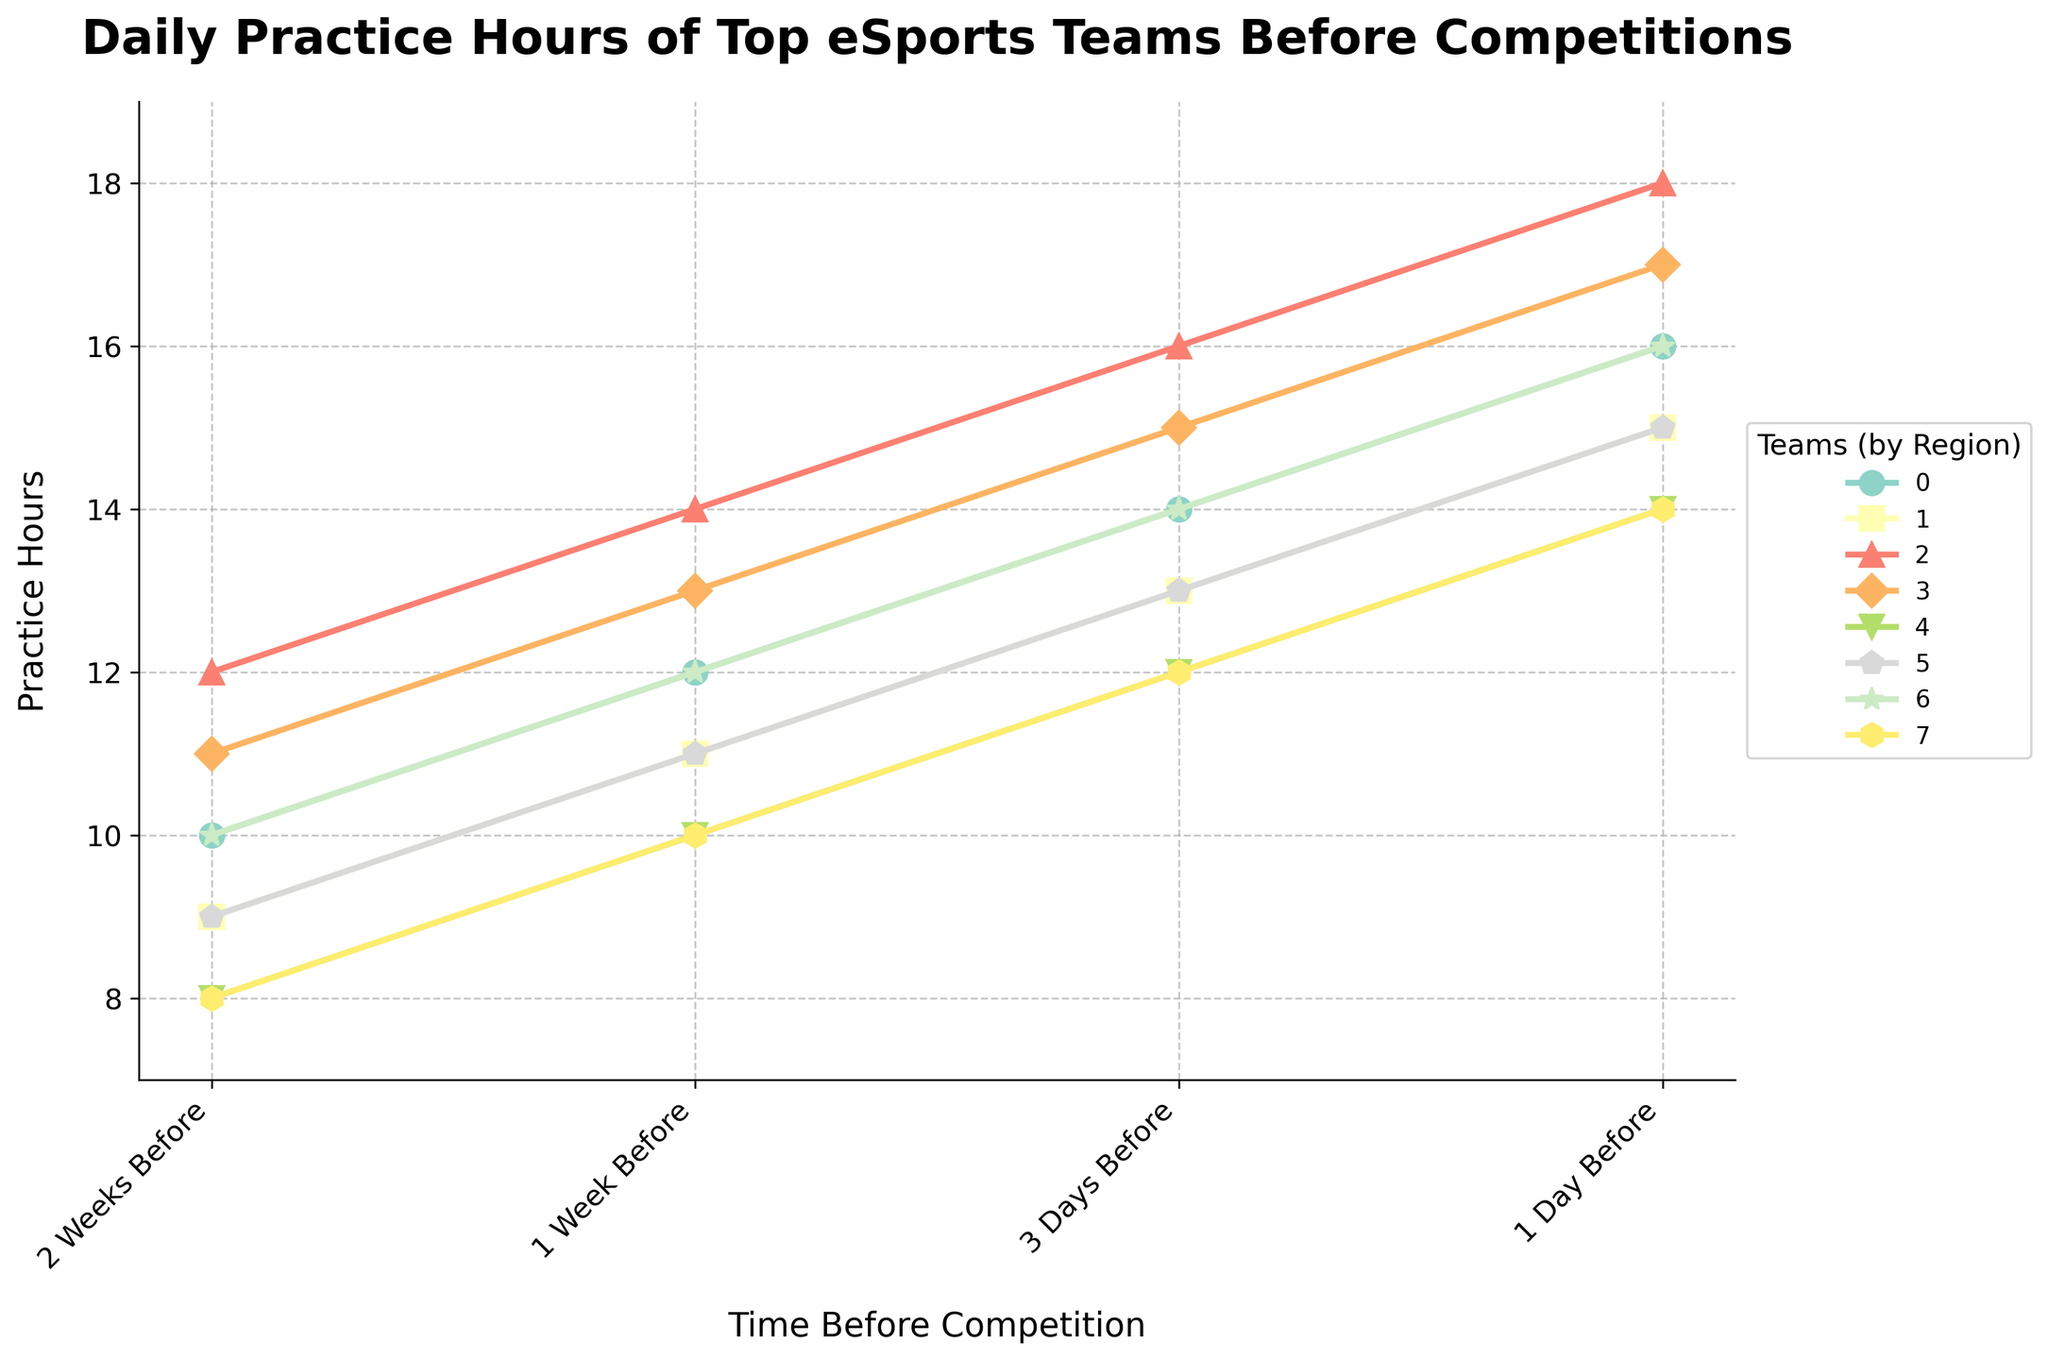Which team has the highest practice hours 1 day before the competition? One day before the competition, the highest value on the y-axis is 18 hours. T1 from South Korea reaches this value on the chart.
Answer: T1 How much do practice hours increase for Team Liquid from 2 weeks to 1 day before the competition? From the chart, Team Liquid's practice hours increase from 10 hours to 16 hours over this period. Therefore, the increase is 16 - 10.
Answer: 6 hours Compare the practice hours for Invictus Gaming and G2 Esports 3 days before the competition. Which team practices more and by how much? Three days before the competition, Invictus Gaming has 15 practice hours while G2 Esports has 13 hours. The difference is 15 - 13 hours.
Answer: Invictus Gaming by 2 hours Which region shows the largest increase in practice hours between the 2 Weeks Before and 1 Week Before time points? To determine the largest increase, we compute the differences: 
North America (2 hours), Europe (2 hours), South Korea (2 hours), China (2 hours), Southeast Asia (2 hours), Brazil (2 hours), CIS (2 hours), Japan (2 hours). 
All regions show the same increase of 2 hours.
Answer: All regions (2 hours) Does any team have a consistent increase in practice hours across all time points? By analyzing each team's trend in the line chart, we see that every team’s practice hours increase progressively without any decrease:
Team Liquid (10, 12, 14, 16), G2 Esports (9, 11, 13, 15), T1 (12, 14, 16, 18), Invictus Gaming (11, 13, 15, 17), BOOM Esports (8, 10, 12, 14), FURIA Esports (9, 11, 13, 15), Natus Vincere (10, 12, 14, 16), DetonatioN FocusMe (8, 10, 12, 14).
Answer: Yes, all teams Which team's practice hours have the steepest increase as the competition draws near? To determine the steepest increase, we look for the line with the steepest slope. T1's line rises from 12 to 18, suggesting a consistent increase of 2 hours per interval.
Answer: T1 (2 hours increase per interval) Compare the practice hours of Southeast Asia (BOOM Esports) and Japan (DetonatioN FocusMe) 2 weeks before and 1 day before the competition. Which team practices more in each case? 2 weeks before: BOOM Esports and DetonatioN FocusMe both have 8 hours. 1 day before: Both have 14 hours according to the chart. Therefore, both teams practice the same amount in both cases.
Answer: Both practice the same Calculate the average practice hours for FURIA Esports over the four time points. The values for FURIA Esports are 9, 11, 13, and 15. Sum these values: 9 + 11 + 13 + 15 = 48. Divide by 4 to find the average: 48 / 4.
Answer: 12 hours Which team has the least practice hours 2 weeks before the competition and how many? On the chart, both BOOM Esports and DetonatioN FocusMe have the least practice hours at 8 hours, 2 weeks before the competition.
Answer: BOOM Esports and DetonatioN FocusMe, 8 hours What is the total increase in practice hours for the CIS team (Natus Vincere) from 2 weeks before to 1 day before the competition? The practice hours for Natus Vincere increase from 10 to 16 hours. So the total increase is 16 - 10.
Answer: 6 hours 